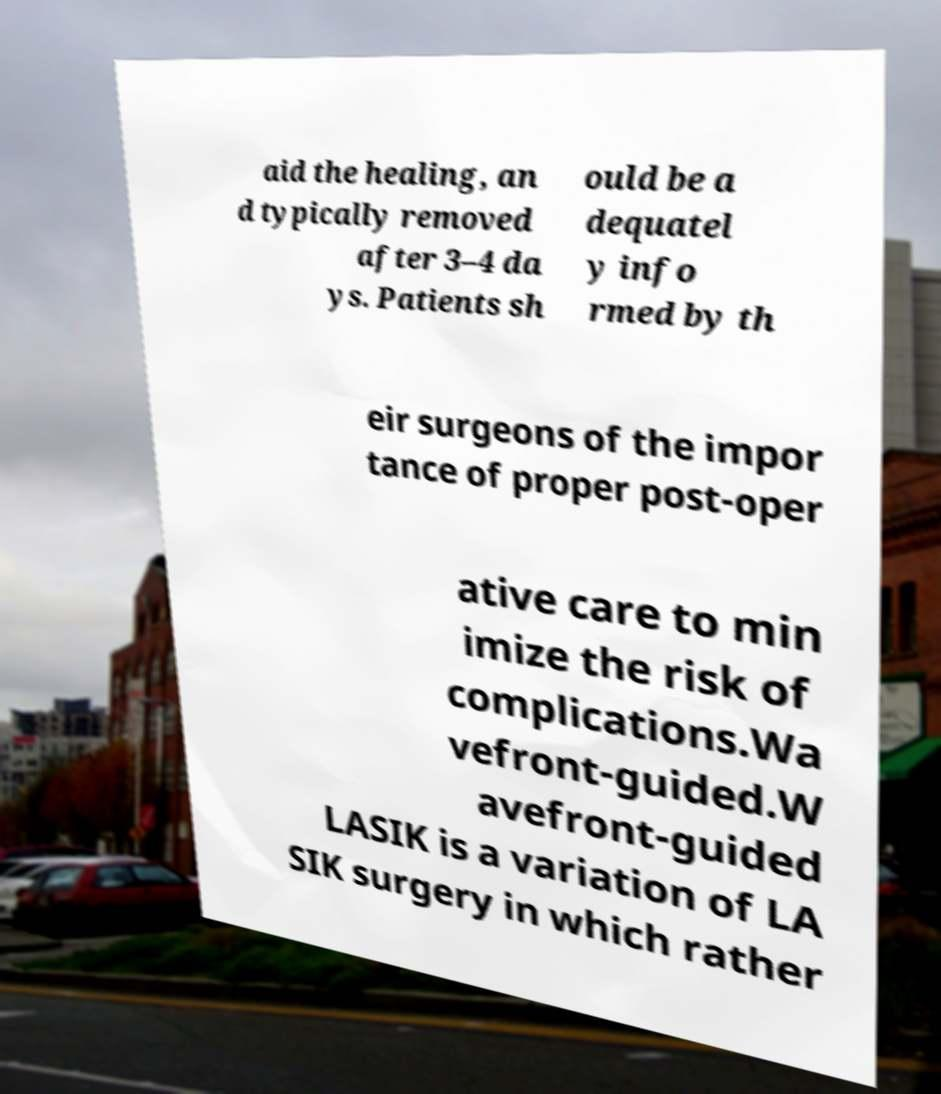Please read and relay the text visible in this image. What does it say? aid the healing, an d typically removed after 3–4 da ys. Patients sh ould be a dequatel y info rmed by th eir surgeons of the impor tance of proper post-oper ative care to min imize the risk of complications.Wa vefront-guided.W avefront-guided LASIK is a variation of LA SIK surgery in which rather 